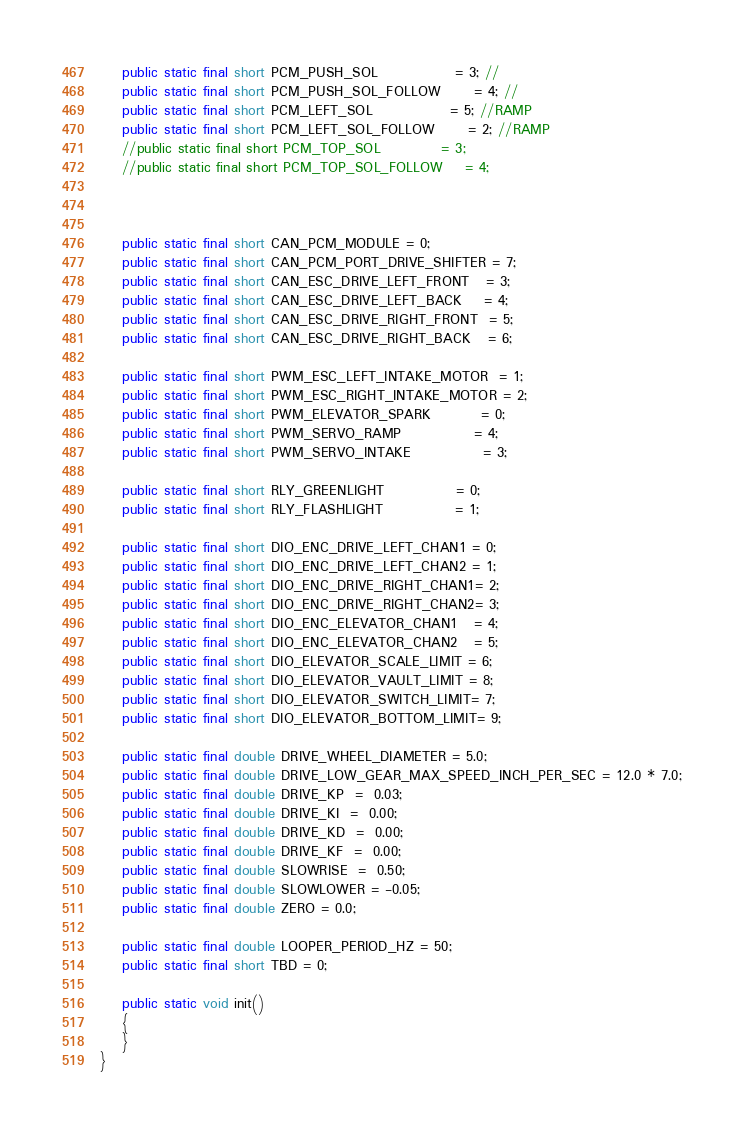<code> <loc_0><loc_0><loc_500><loc_500><_Java_>	public static final short PCM_PUSH_SOL			  = 3; //
	public static final short PCM_PUSH_SOL_FOLLOW	  = 4; //
	public static final short PCM_LEFT_SOL 			  = 5; //RAMP
	public static final short PCM_LEFT_SOL_FOLLOW 	  = 2; //RAMP
	//public static final short PCM_TOP_SOL			  = 3;
	//public static final short PCM_TOP_SOL_FOLLOW    = 4;
	
	
	
	public static final short CAN_PCM_MODULE = 0;
	public static final short CAN_PCM_PORT_DRIVE_SHIFTER = 7;
	public static final short CAN_ESC_DRIVE_LEFT_FRONT   = 3;
	public static final short CAN_ESC_DRIVE_LEFT_BACK    = 4;
	public static final short CAN_ESC_DRIVE_RIGHT_FRONT  = 5;
	public static final short CAN_ESC_DRIVE_RIGHT_BACK   = 6;

	public static final short PWM_ESC_LEFT_INTAKE_MOTOR  = 1;
	public static final short PWM_ESC_RIGHT_INTAKE_MOTOR = 2;
	public static final short PWM_ELEVATOR_SPARK         = 0;
	public static final short PWM_SERVO_RAMP			 = 4;
	public static final short PWM_SERVO_INTAKE			 = 3;
	
	public static final short RLY_GREENLIGHT             = 0;
	public static final short RLY_FLASHLIGHT             = 1;

	public static final short DIO_ENC_DRIVE_LEFT_CHAN1 = 0;
	public static final short DIO_ENC_DRIVE_LEFT_CHAN2 = 1;
	public static final short DIO_ENC_DRIVE_RIGHT_CHAN1= 2;
	public static final short DIO_ENC_DRIVE_RIGHT_CHAN2= 3;
	public static final short DIO_ENC_ELEVATOR_CHAN1   = 4;
	public static final short DIO_ENC_ELEVATOR_CHAN2   = 5;
	public static final short DIO_ELEVATOR_SCALE_LIMIT = 6;
	public static final short DIO_ELEVATOR_VAULT_LIMIT = 8;
	public static final short DIO_ELEVATOR_SWITCH_LIMIT= 7;
	public static final short DIO_ELEVATOR_BOTTOM_LIMIT= 9;

	public static final double DRIVE_WHEEL_DIAMETER = 5.0;
	public static final double DRIVE_LOW_GEAR_MAX_SPEED_INCH_PER_SEC = 12.0 * 7.0;
	public static final double DRIVE_KP  =  0.03;
	public static final double DRIVE_KI  =  0.00;
	public static final double DRIVE_KD  =  0.00;
	public static final double DRIVE_KF  =  0.00;
	public static final double SLOWRISE  =  0.50;
	public static final double SLOWLOWER = -0.05;
	public static final double ZERO = 0.0;

	public static final double LOOPER_PERIOD_HZ = 50;
	public static final short TBD = 0;

	public static void init()
	{
	}
}
</code> 